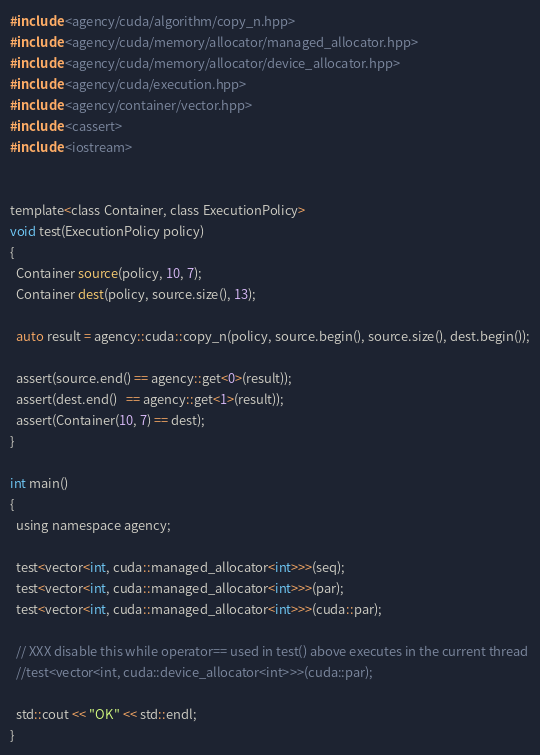<code> <loc_0><loc_0><loc_500><loc_500><_Cuda_>#include <agency/cuda/algorithm/copy_n.hpp>
#include <agency/cuda/memory/allocator/managed_allocator.hpp>
#include <agency/cuda/memory/allocator/device_allocator.hpp>
#include <agency/cuda/execution.hpp>
#include <agency/container/vector.hpp>
#include <cassert>
#include <iostream>


template<class Container, class ExecutionPolicy>
void test(ExecutionPolicy policy)
{
  Container source(policy, 10, 7);
  Container dest(policy, source.size(), 13);

  auto result = agency::cuda::copy_n(policy, source.begin(), source.size(), dest.begin());

  assert(source.end() == agency::get<0>(result));
  assert(dest.end()   == agency::get<1>(result));
  assert(Container(10, 7) == dest);
}

int main()
{
  using namespace agency;

  test<vector<int, cuda::managed_allocator<int>>>(seq);
  test<vector<int, cuda::managed_allocator<int>>>(par);
  test<vector<int, cuda::managed_allocator<int>>>(cuda::par);

  // XXX disable this while operator== used in test() above executes in the current thread
  //test<vector<int, cuda::device_allocator<int>>>(cuda::par);

  std::cout << "OK" << std::endl;
}

</code> 